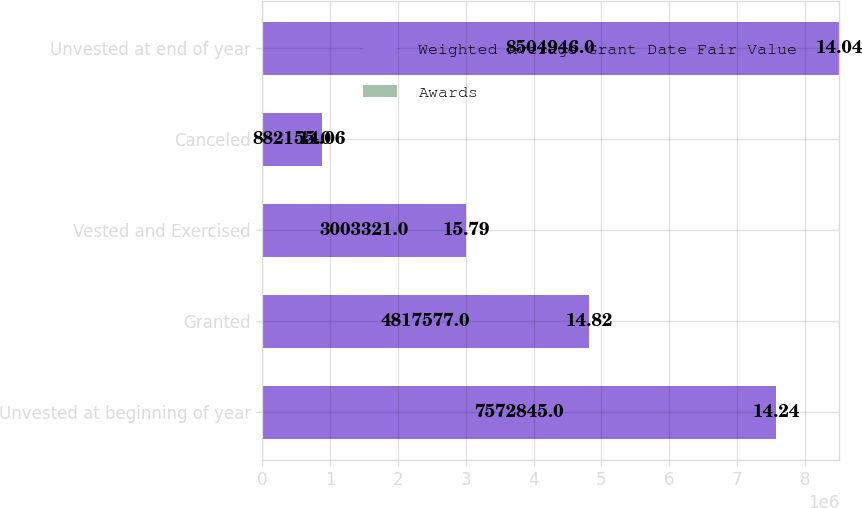Convert chart to OTSL. <chart><loc_0><loc_0><loc_500><loc_500><stacked_bar_chart><ecel><fcel>Unvested at beginning of year<fcel>Granted<fcel>Vested and Exercised<fcel>Canceled<fcel>Unvested at end of year<nl><fcel>Weighted Average Grant Date Fair Value<fcel>7.57284e+06<fcel>4.81758e+06<fcel>3.00332e+06<fcel>882155<fcel>8.50495e+06<nl><fcel>Awards<fcel>14.24<fcel>14.82<fcel>15.79<fcel>14.06<fcel>14.04<nl></chart> 